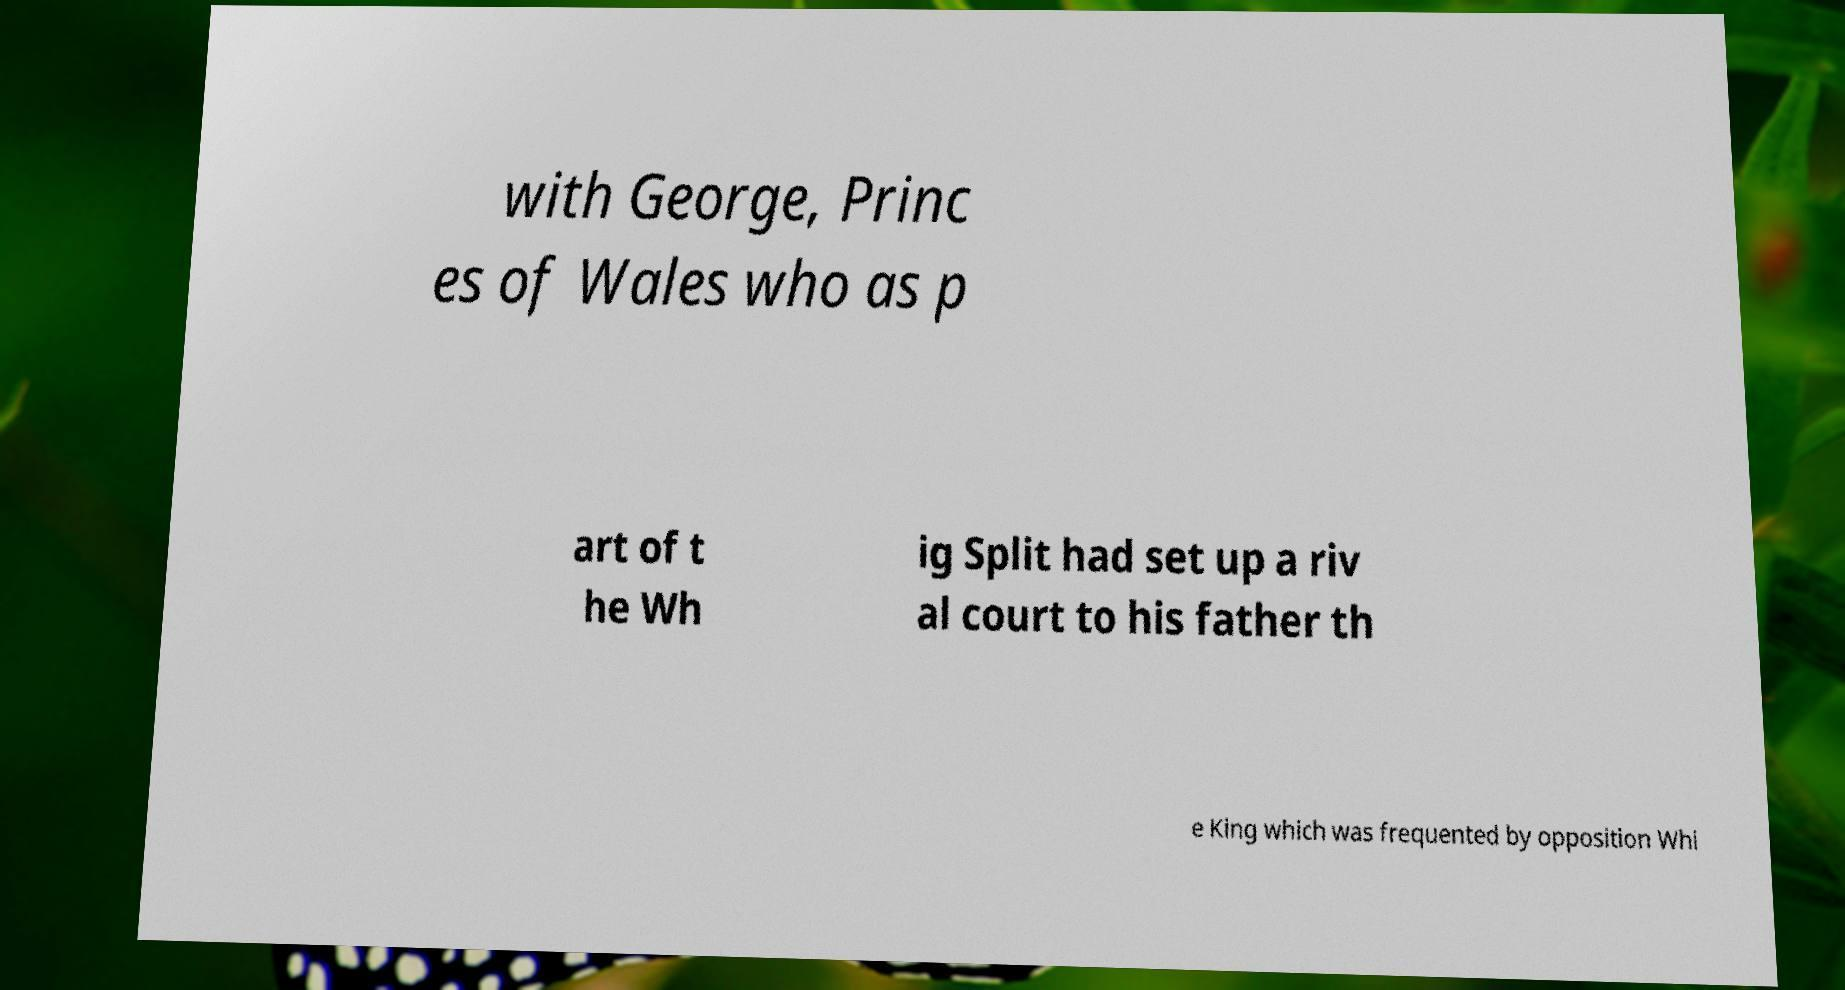Could you extract and type out the text from this image? with George, Princ es of Wales who as p art of t he Wh ig Split had set up a riv al court to his father th e King which was frequented by opposition Whi 